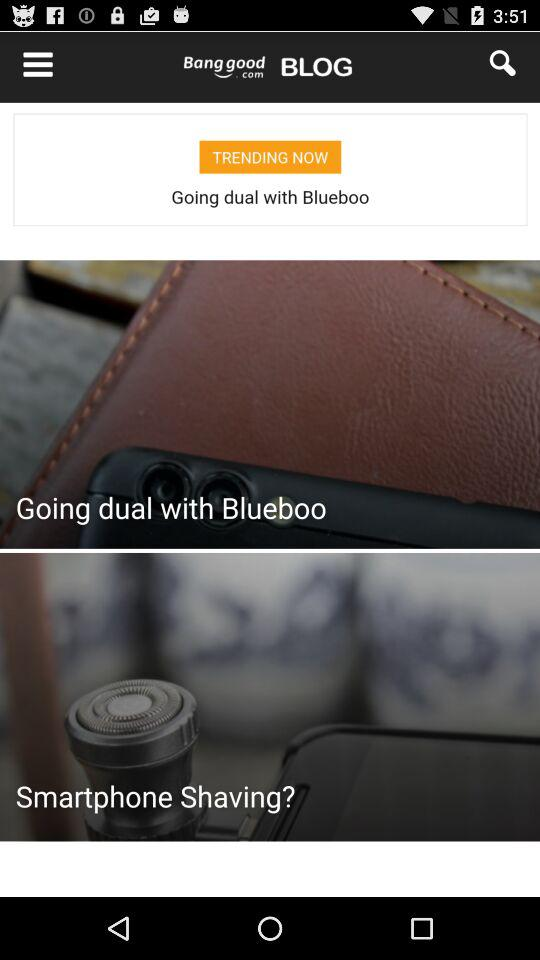What is the price of the "Bow Belt Solid Color Mesh Tulle Pleated High Waist Women Maxi Skirt"? The price is US$20.99. 